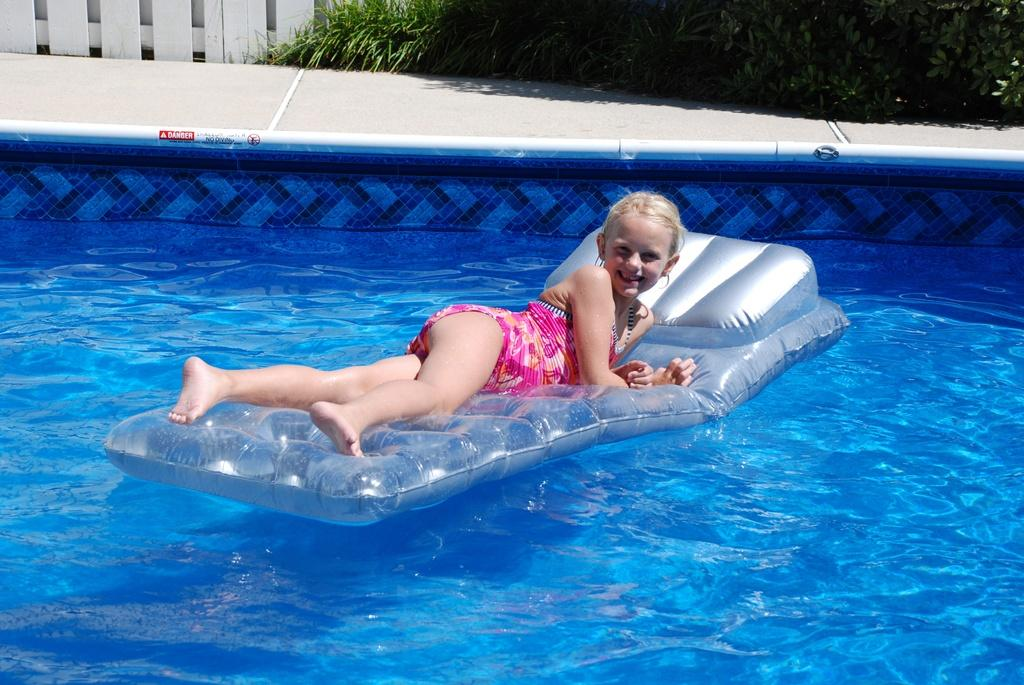Who is the main subject in the image? There is a girl in the image. What is the girl doing in the image? The girl is laying on an air floating bed in a pool. What can be seen in the background of the image? There is water visible in the image, as well as plants on the side of the pool. What type of barrier is present in the image? There is a wooden fence in the image. Can you see a robin perched on the wooden fence in the image? There is no robin present in the image; it only features a girl on an air floating bed in a pool, surrounded by water, plants, and a wooden fence. 